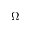Convert formula to latex. <formula><loc_0><loc_0><loc_500><loc_500>\Omega</formula> 